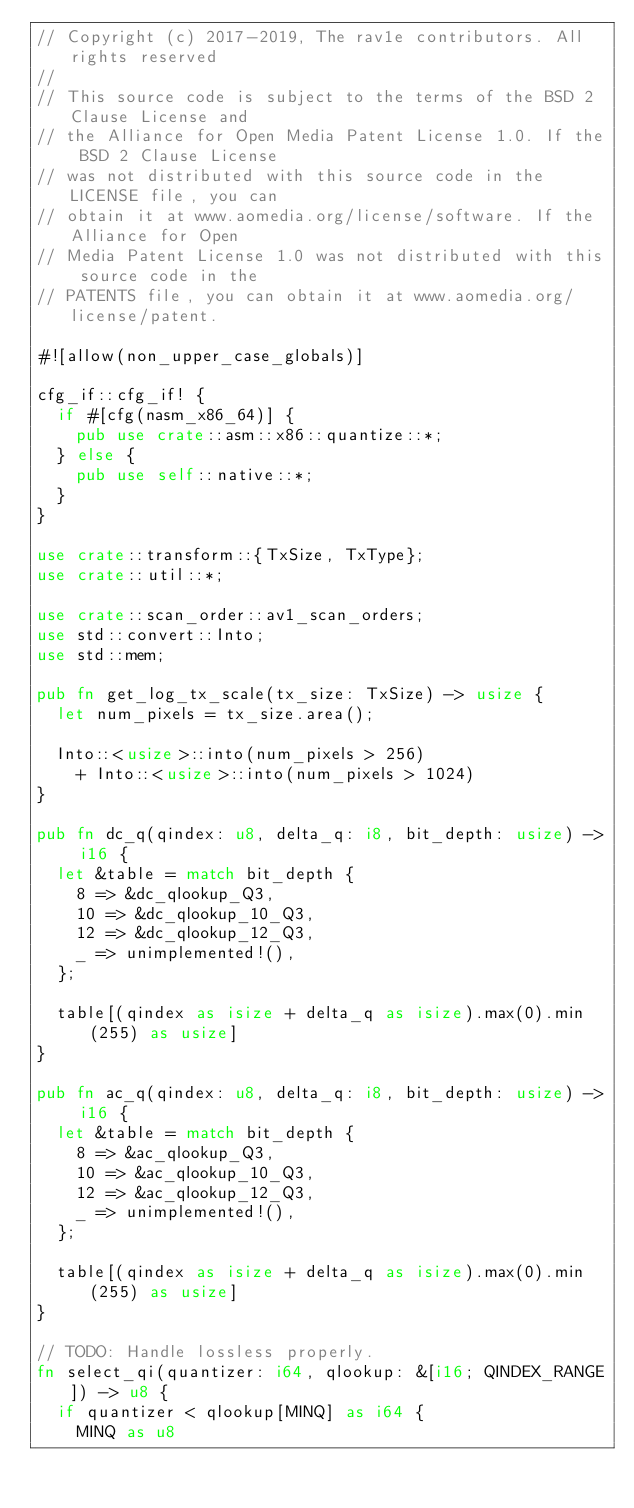<code> <loc_0><loc_0><loc_500><loc_500><_Rust_>// Copyright (c) 2017-2019, The rav1e contributors. All rights reserved
//
// This source code is subject to the terms of the BSD 2 Clause License and
// the Alliance for Open Media Patent License 1.0. If the BSD 2 Clause License
// was not distributed with this source code in the LICENSE file, you can
// obtain it at www.aomedia.org/license/software. If the Alliance for Open
// Media Patent License 1.0 was not distributed with this source code in the
// PATENTS file, you can obtain it at www.aomedia.org/license/patent.

#![allow(non_upper_case_globals)]

cfg_if::cfg_if! {
  if #[cfg(nasm_x86_64)] {
    pub use crate::asm::x86::quantize::*;
  } else {
    pub use self::native::*;
  }
}

use crate::transform::{TxSize, TxType};
use crate::util::*;

use crate::scan_order::av1_scan_orders;
use std::convert::Into;
use std::mem;

pub fn get_log_tx_scale(tx_size: TxSize) -> usize {
  let num_pixels = tx_size.area();

  Into::<usize>::into(num_pixels > 256)
    + Into::<usize>::into(num_pixels > 1024)
}

pub fn dc_q(qindex: u8, delta_q: i8, bit_depth: usize) -> i16 {
  let &table = match bit_depth {
    8 => &dc_qlookup_Q3,
    10 => &dc_qlookup_10_Q3,
    12 => &dc_qlookup_12_Q3,
    _ => unimplemented!(),
  };

  table[(qindex as isize + delta_q as isize).max(0).min(255) as usize]
}

pub fn ac_q(qindex: u8, delta_q: i8, bit_depth: usize) -> i16 {
  let &table = match bit_depth {
    8 => &ac_qlookup_Q3,
    10 => &ac_qlookup_10_Q3,
    12 => &ac_qlookup_12_Q3,
    _ => unimplemented!(),
  };

  table[(qindex as isize + delta_q as isize).max(0).min(255) as usize]
}

// TODO: Handle lossless properly.
fn select_qi(quantizer: i64, qlookup: &[i16; QINDEX_RANGE]) -> u8 {
  if quantizer < qlookup[MINQ] as i64 {
    MINQ as u8</code> 